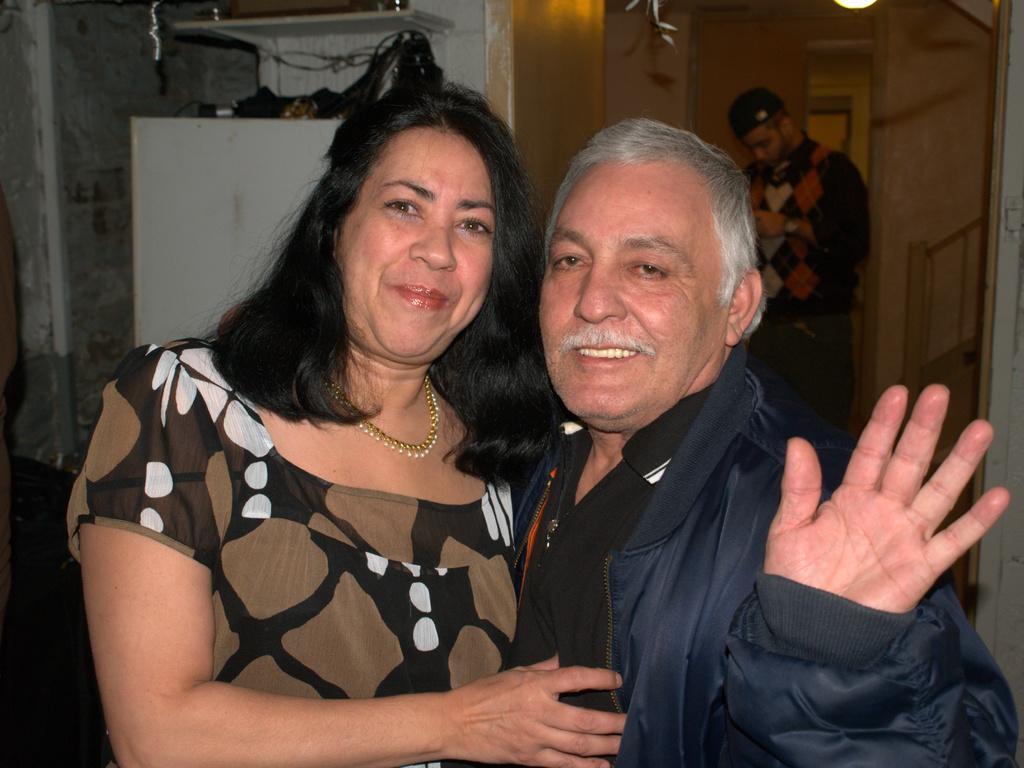Can you describe this image briefly? This picture is an inside view of a room. In the center of the image we can see two persons are standing and smiling. In the background of the image we can see the wall, shelves, lights, a person, stairs, door and some objects. 